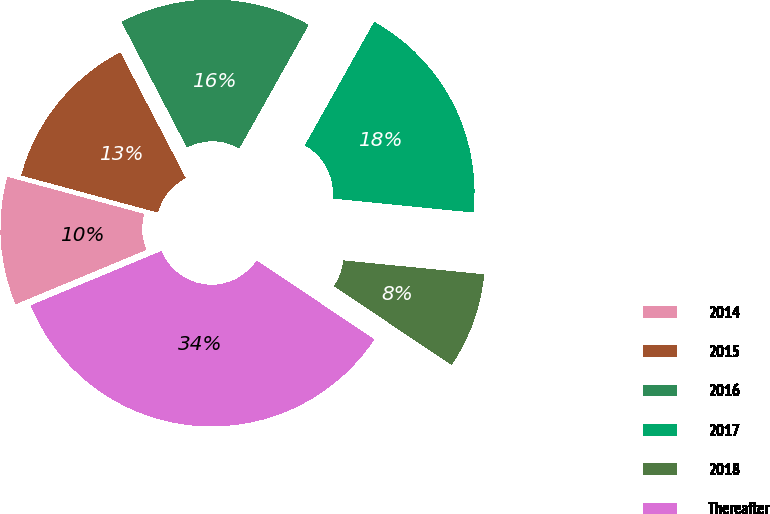<chart> <loc_0><loc_0><loc_500><loc_500><pie_chart><fcel>2014<fcel>2015<fcel>2016<fcel>2017<fcel>2018<fcel>Thereafter<nl><fcel>10.49%<fcel>13.14%<fcel>15.78%<fcel>18.43%<fcel>7.84%<fcel>34.31%<nl></chart> 